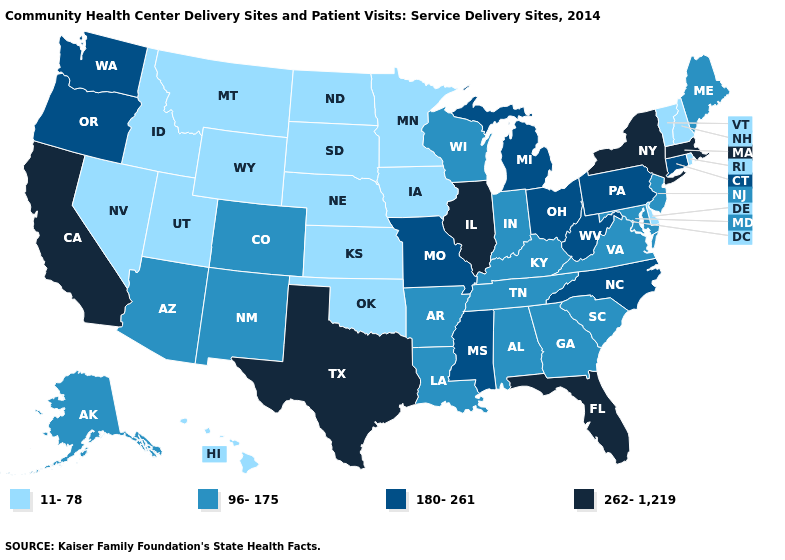Name the states that have a value in the range 96-175?
Concise answer only. Alabama, Alaska, Arizona, Arkansas, Colorado, Georgia, Indiana, Kentucky, Louisiana, Maine, Maryland, New Jersey, New Mexico, South Carolina, Tennessee, Virginia, Wisconsin. What is the lowest value in the USA?
Quick response, please. 11-78. Name the states that have a value in the range 180-261?
Give a very brief answer. Connecticut, Michigan, Mississippi, Missouri, North Carolina, Ohio, Oregon, Pennsylvania, Washington, West Virginia. What is the lowest value in states that border Alabama?
Write a very short answer. 96-175. Name the states that have a value in the range 11-78?
Concise answer only. Delaware, Hawaii, Idaho, Iowa, Kansas, Minnesota, Montana, Nebraska, Nevada, New Hampshire, North Dakota, Oklahoma, Rhode Island, South Dakota, Utah, Vermont, Wyoming. Which states have the highest value in the USA?
Write a very short answer. California, Florida, Illinois, Massachusetts, New York, Texas. What is the value of Kansas?
Short answer required. 11-78. Among the states that border Wisconsin , does Michigan have the highest value?
Concise answer only. No. What is the lowest value in the Northeast?
Give a very brief answer. 11-78. Does Oregon have the highest value in the USA?
Answer briefly. No. Which states have the highest value in the USA?
Answer briefly. California, Florida, Illinois, Massachusetts, New York, Texas. Does California have a higher value than Massachusetts?
Quick response, please. No. Name the states that have a value in the range 96-175?
Concise answer only. Alabama, Alaska, Arizona, Arkansas, Colorado, Georgia, Indiana, Kentucky, Louisiana, Maine, Maryland, New Jersey, New Mexico, South Carolina, Tennessee, Virginia, Wisconsin. Does Arizona have the same value as Iowa?
Be succinct. No. Does Florida have a lower value than Washington?
Concise answer only. No. 